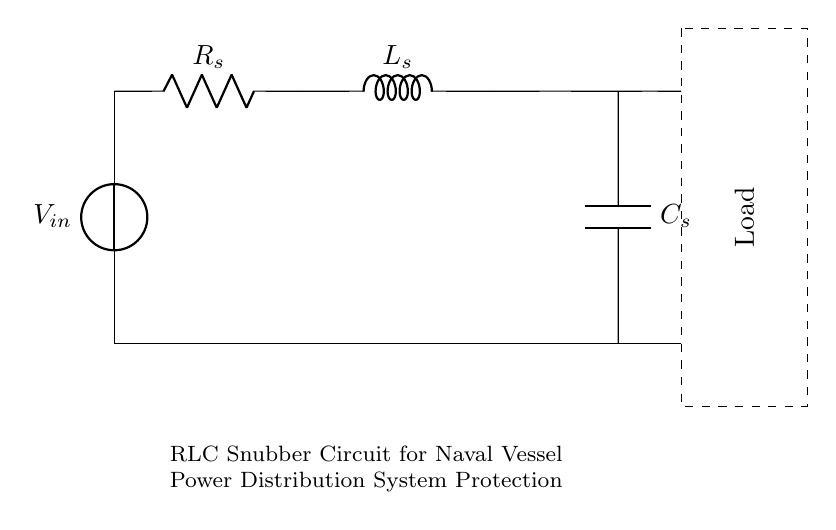What is the type of circuit depicted? The circuit shown is an RLC snubber circuit, characterized by the presence of a resistor (R), an inductor (L), and a capacitor (C) connected in series. This snubber circuit is specifically designed to mitigate voltage spikes in power distribution systems.
Answer: RLC snubber circuit What is the purpose of the resistor in this circuit? The resistor acts to dissipate energy, provide damping, and limit the inrush current that occurs when the circuit experiences transient conditions, thus protecting other components from damage.
Answer: Damping What is the value of the voltage source in the circuit? The voltage source is denoted as V_in, indicating it supplies the input voltage to the circuit. Specific numerical values aren't provided in the diagram, but it indicates the presence of voltage in the circuit.
Answer: V_in How many components are in the RLC snubber circuit? There are three main components: one resistor, one inductor, and one capacitor, making a total of three essential circuit elements.
Answer: Three Describe the configuration of the circuit components. The components are connected in series: the resistor is followed by the inductor, which is then followed by the capacitor, creating a continuous path for current flow through all components.
Answer: Series configuration What role does the capacitor play in the circuit? The capacitor is responsible for storing electrical energy and providing a path for high-frequency transients, helping to filter or smooth out voltage spikes caused by switching operations within the power distribution system.
Answer: Energy storage 